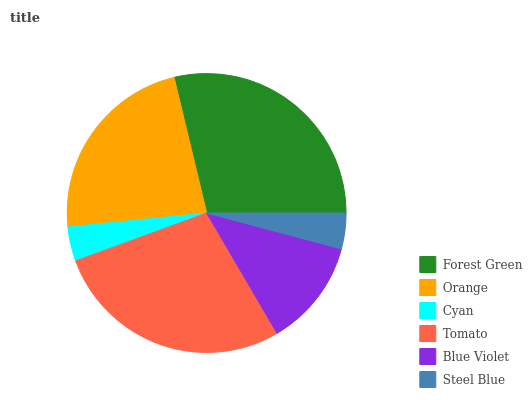Is Cyan the minimum?
Answer yes or no. Yes. Is Forest Green the maximum?
Answer yes or no. Yes. Is Orange the minimum?
Answer yes or no. No. Is Orange the maximum?
Answer yes or no. No. Is Forest Green greater than Orange?
Answer yes or no. Yes. Is Orange less than Forest Green?
Answer yes or no. Yes. Is Orange greater than Forest Green?
Answer yes or no. No. Is Forest Green less than Orange?
Answer yes or no. No. Is Orange the high median?
Answer yes or no. Yes. Is Blue Violet the low median?
Answer yes or no. Yes. Is Tomato the high median?
Answer yes or no. No. Is Orange the low median?
Answer yes or no. No. 